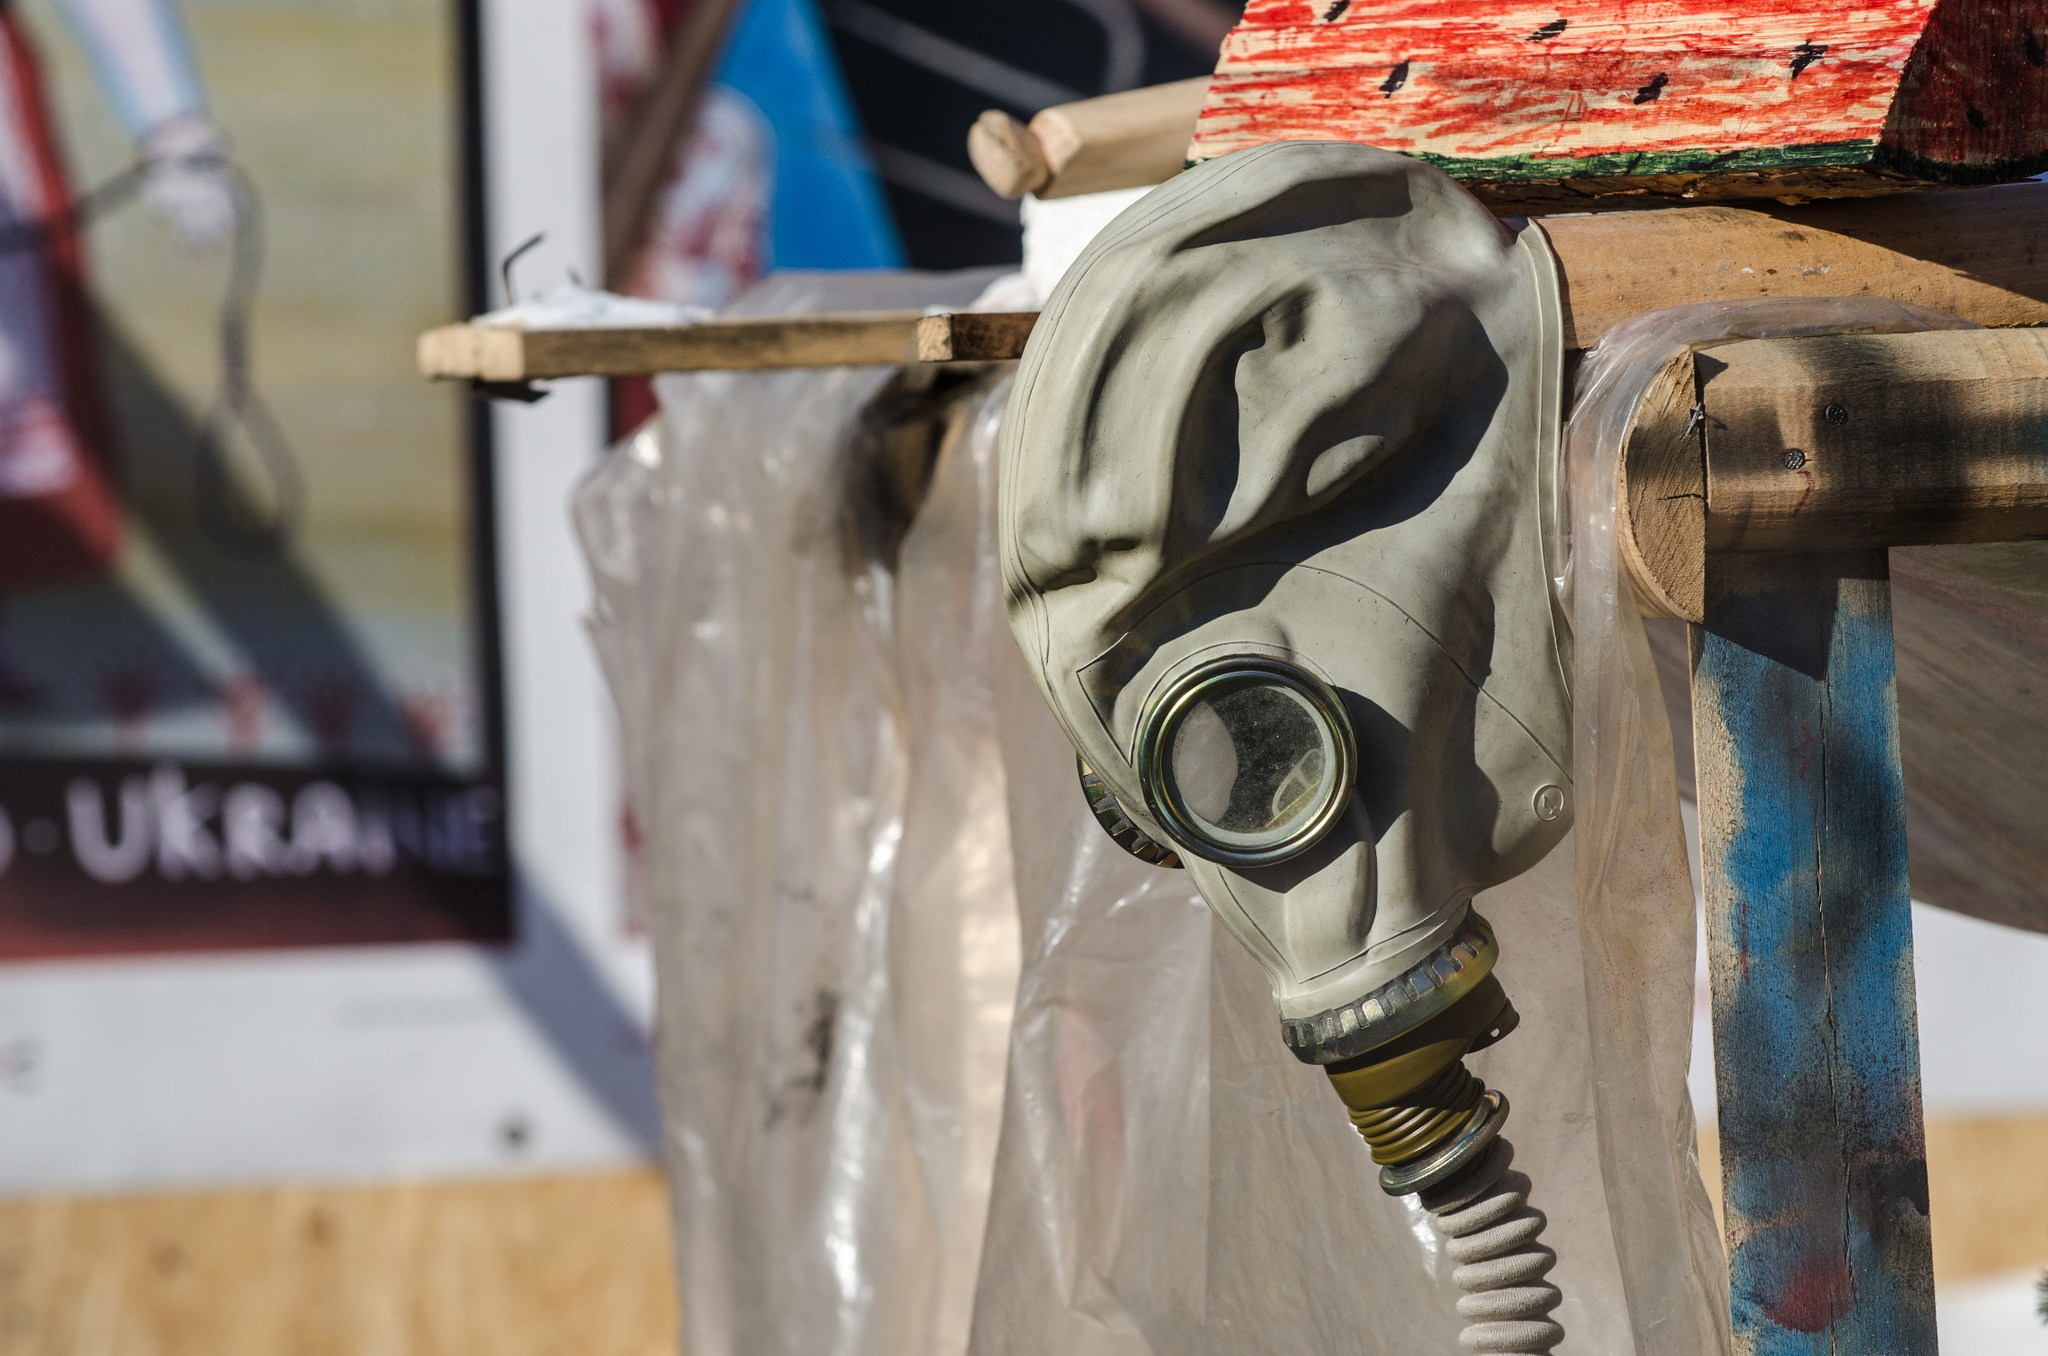Can you describe the symbolic meanings that might be associated with this gas mask display? Symbolically, the gas mask might represent preparedness and protection in the face of adversity or danger, reflecting a universal theme of human survival through difficult times. In a specific Ukrainian context, it might also evoke memories of past military or chemical threats, symbolizing both vulnerability and the strength to persevere. The rustic and makeshift display could further symbolize resourcefulness and resilience, key traits in facing and overcoming crises. 